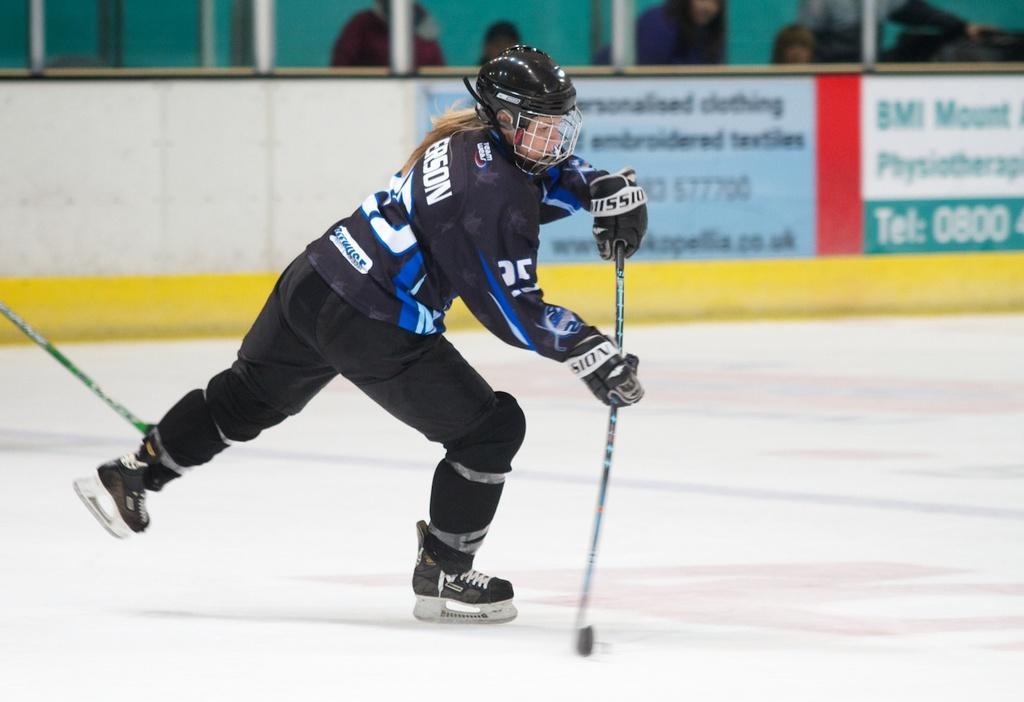Could you give a brief overview of what you see in this image? In the picture we can see a woman wearing black color dress, helmet playing ice hockey and in the background there is board, there are some persons standing. 